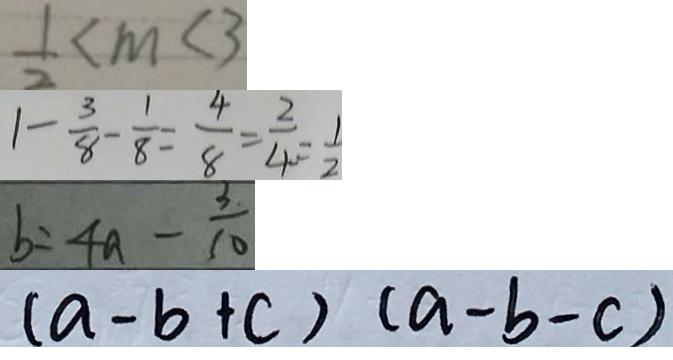<formula> <loc_0><loc_0><loc_500><loc_500>\frac { 1 } { 2 } < m < 3 
 1 - \frac { 3 } { 8 } - \frac { 1 } { 8 } = \frac { 4 } { 8 } = \frac { 2 } { 4 } = \frac { 1 } { 2 } 
 b = 4 a - \frac { 3 } { 1 0 } 
 ( a - b + c ) ( a - b - c )</formula> 